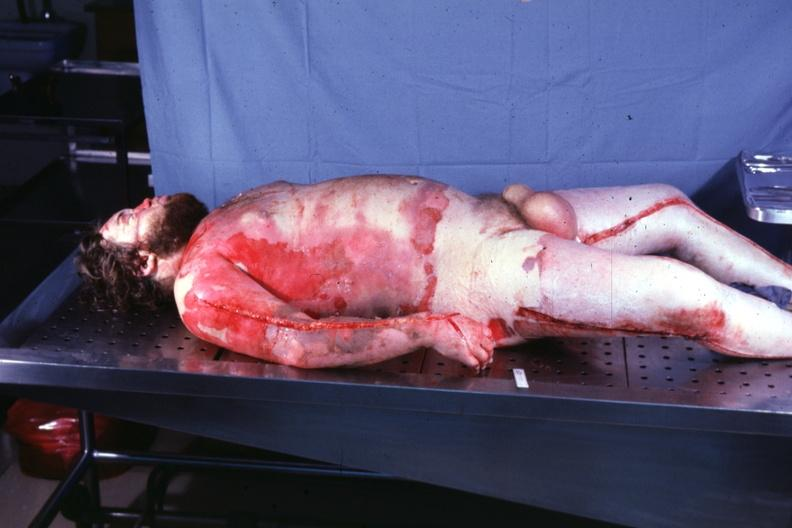does situs inversus show body burns 24 hours prior now anasarca?
Answer the question using a single word or phrase. No 